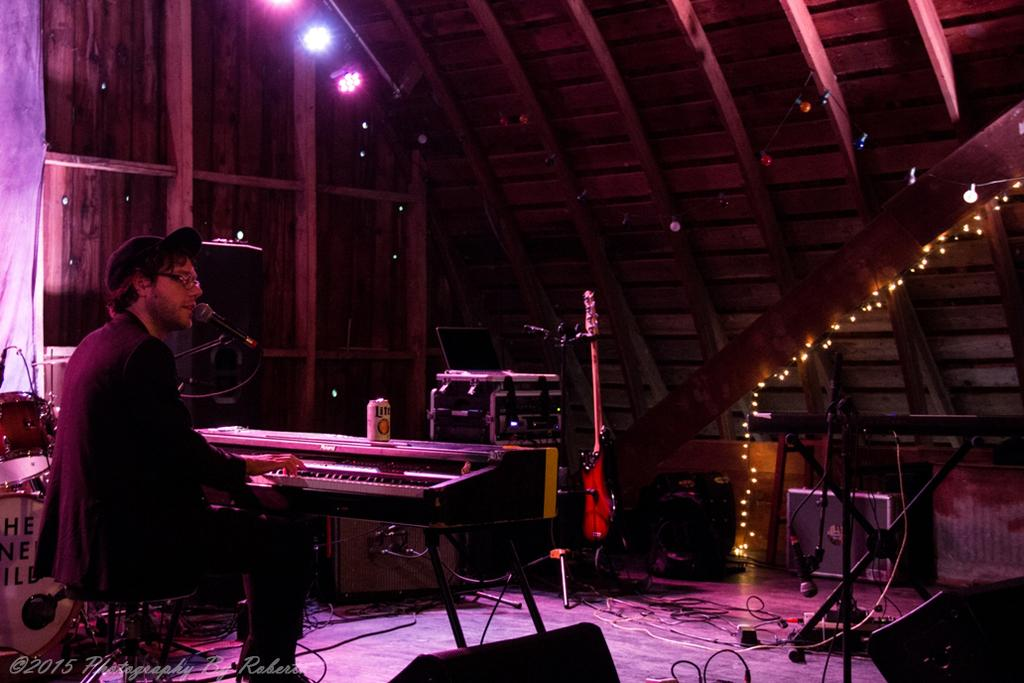What is the man in the image doing? The man is seated, playing a piano, singing, and using a microphone. What can be inferred about the man's activity in the image? The man is likely performing or entertaining, given the presence of a piano, microphone, and singing. What else is visible in the image besides the man and his activities? There are lights visible in the image. What type of cake is being served to the coach in the image? There is no coach or cake present in the image; it features a man playing a piano, singing, and using a microphone. 